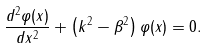Convert formula to latex. <formula><loc_0><loc_0><loc_500><loc_500>\frac { d ^ { 2 } \varphi ( x ) } { d x ^ { 2 } } + \left ( k ^ { 2 } - \beta ^ { 2 } \right ) \varphi ( x ) = 0 .</formula> 